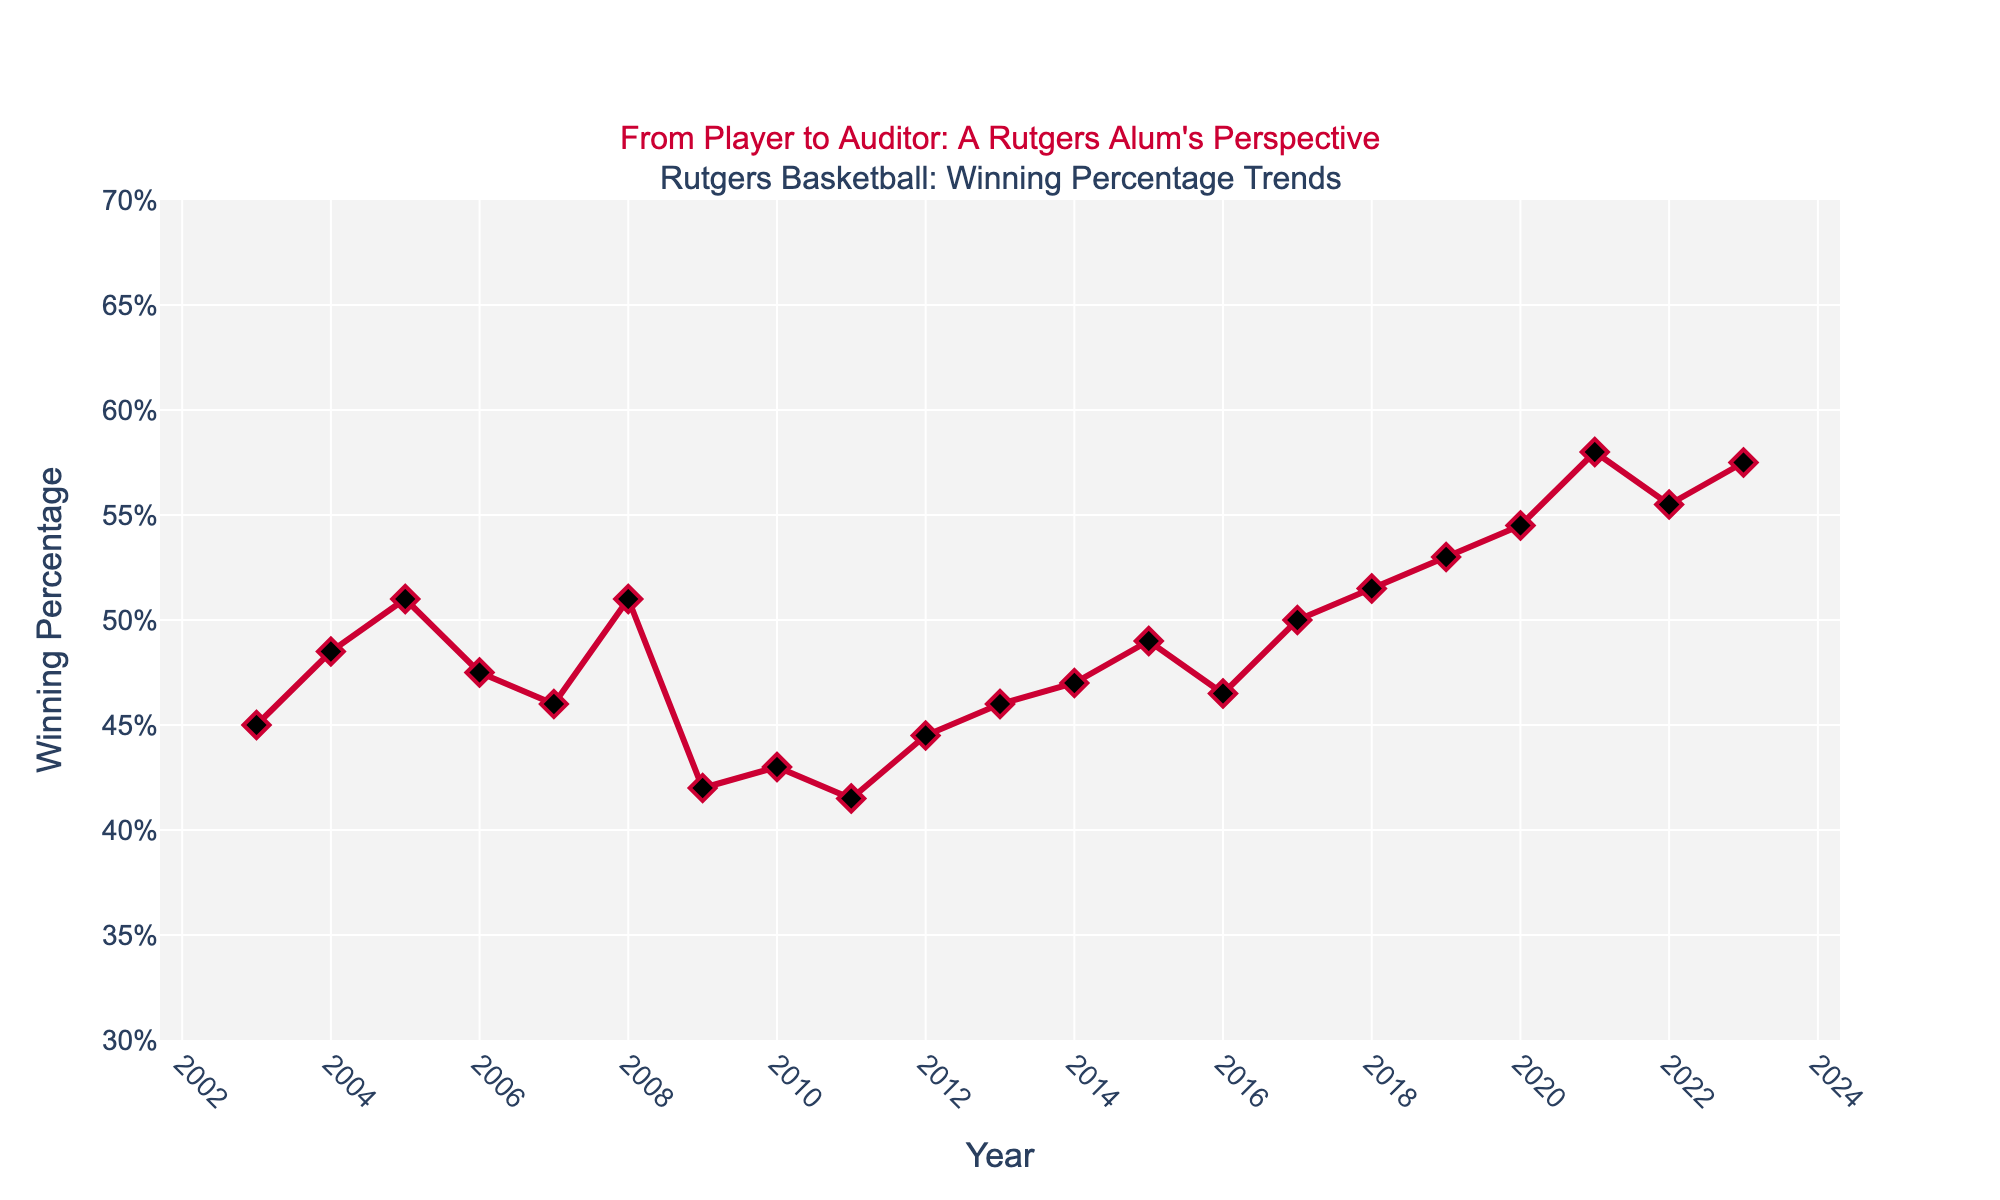1. What is the highest winning percentage achieved by the Rutgers basketball team in the past 20 years? To find the highest winning percentage, look for the highest point on the plot. The highest point occurs in 2021 with a winning percentage of 0.580.
Answer: 0.580 2. How many years did the Rutgers basketball team have a winning percentage below 0.500? Count the number of data points below the 0.500 line. Points below 0.500 are in 2003, 2004, 2006, 2007, 2009, 2010, 2011, 2012, 2013, 2014, and 2016, totaling 11 years.
Answer: 11 years 3. What is the trend in winning percentage from 2018 to 2021? Observe the plot from 2018 to 2021. The winning percentage increases steadily from 0.515 in 2018 to 0.530 in 2019, then to 0.545 in 2020, and finally 0.580 in 2021.
Answer: Increasing trend 4. Which year had the lowest winning percentage, and what was the value? Identify the lowest point on the plot. The lowest point occurs in 2009 with a winning percentage of 0.420.
Answer: 2009, 0.420 5. What was the winning percentage in 2005, and how does it compare to 2006? Find the values for 2005 and 2006 on the plot. In 2005, the winning percentage was 0.510, and in 2006, it was 0.475. Comparing the two, 2005 has a higher winning percentage than 2006.
Answer: 0.510 in 2005, higher than 2006 6. What is the average winning percentage over the past 20 years? Sum all the winning percentages and divide by the number of years (20). (0.450+0.485+0.510+0.475+0.460+0.510+0.420+0.430+0.415+0.445+0.460+0.470+0.490+0.465+0.500+0.515+0.530+0.545+0.580+0.555+0.575) / 20 = 0.48825
Answer: 0.48825 7. Did the winning percentage ever remain the same for two consecutive years? Examine the plot for any flat lines indicating no change year over year. There are no consecutive years with the same winning percentage.
Answer: No 8. How did the winning percentage change from 2007 to 2008? Look at the values for 2007 and 2008. In 2007, the winning percentage was 0.460, and in 2008, it increased to 0.510. The change is 0.510 - 0.460 = 0.050.
Answer: Increased by 0.050 9. Which year shows the most significant improvement in winning percentage compared to the previous year? Observe the year-to-year changes and find the largest increase. The largest increase is from 2020 (0.545) to 2021 (0.580), an improvement of 0.035.
Answer: 2021 10. How often did the winning percentage exceed 0.500 in the past 20 years? Count the number of points above the 0.500 line. Points above 0.500 are in 2005, 2008, 2017, 2018, 2019, 2020, 2021, 2022, and 2023, totaling 9 years.
Answer: 9 years 